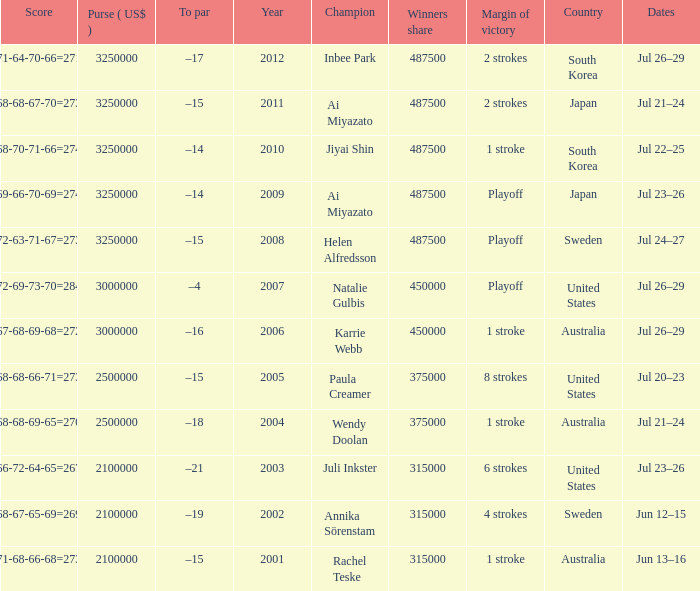What is the lowest year listed? 2001.0. 